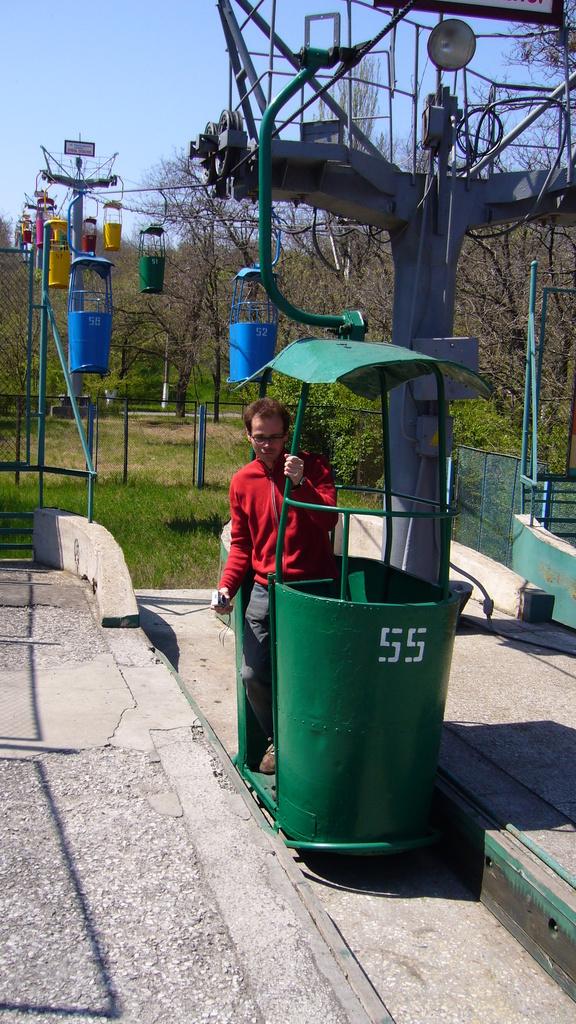How many carts are there?
Ensure brevity in your answer.  1. 